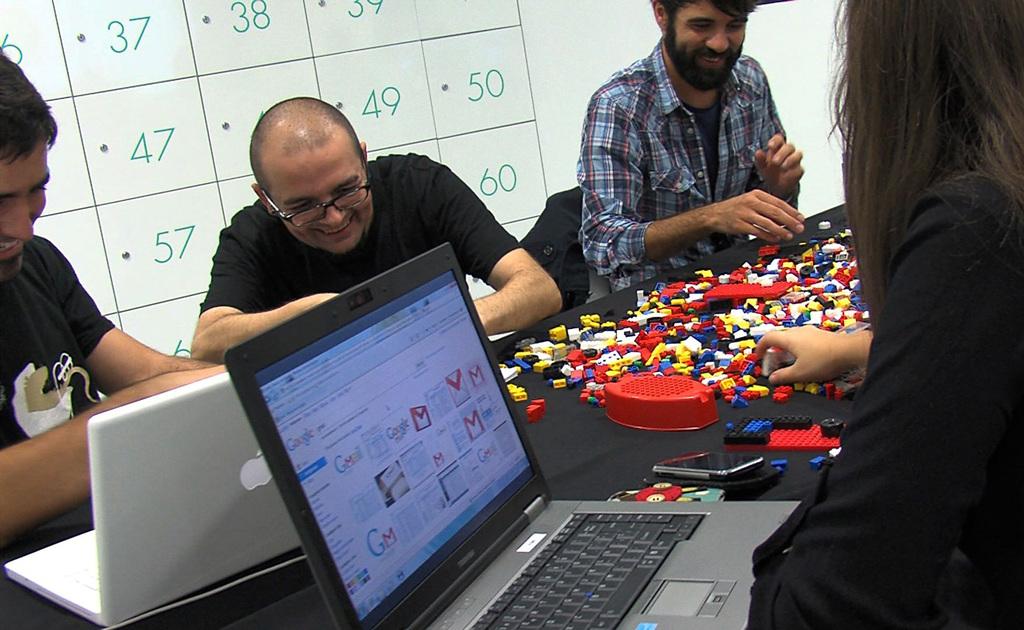What is the most lower right number on the board?
Offer a very short reply. 60. What is the top left number?
Provide a short and direct response. 37. 